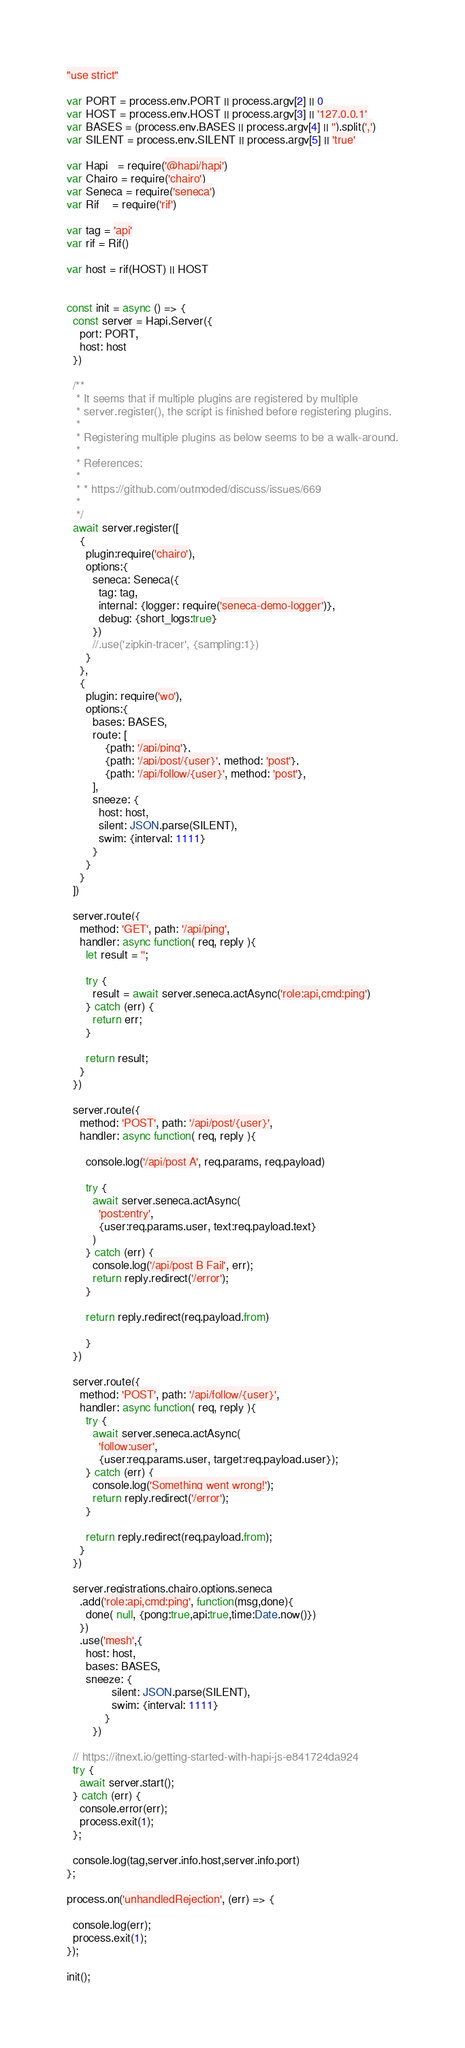<code> <loc_0><loc_0><loc_500><loc_500><_JavaScript_>"use strict"

var PORT = process.env.PORT || process.argv[2] || 0
var HOST = process.env.HOST || process.argv[3] || '127.0.0.1'
var BASES = (process.env.BASES || process.argv[4] || '').split(',')
var SILENT = process.env.SILENT || process.argv[5] || 'true'

var Hapi   = require('@hapi/hapi')
var Chairo = require('chairo')
var Seneca = require('seneca')
var Rif    = require('rif')

var tag = 'api'
var rif = Rif()

var host = rif(HOST) || HOST


const init = async () => {
  const server = Hapi.Server({
    port: PORT,
    host: host
  })
  
  /**
   * It seems that if multiple plugins are registered by multiple
   * server.register(), the script is finished before registering plugins.
   * 
   * Registering multiple plugins as below seems to be a walk-around.
   * 
   * References:
   * 
   * * https://github.com/outmoded/discuss/issues/669
   * 
   */
  await server.register([
    {
      plugin:require('chairo'),
      options:{
        seneca: Seneca({
          tag: tag,
          internal: {logger: require('seneca-demo-logger')},
          debug: {short_logs:true}
        })
        //.use('zipkin-tracer', {sampling:1})
      }
    },
    {
      plugin: require('wo'),
      options:{
        bases: BASES,
        route: [
            {path: '/api/ping'},
            {path: '/api/post/{user}', method: 'post'},
            {path: '/api/follow/{user}', method: 'post'},
        ],
        sneeze: {
          host: host,
          silent: JSON.parse(SILENT),
          swim: {interval: 1111}
        }
      }
    }
  ])

  server.route({
    method: 'GET', path: '/api/ping',
    handler: async function( req, reply ){
      let result = '';

      try {
        result = await server.seneca.actAsync('role:api,cmd:ping')
      } catch (err) {
        return err;
      }

      return result;
    }
  })
  
  server.route({
    method: 'POST', path: '/api/post/{user}',
    handler: async function( req, reply ){
  
      console.log('/api/post A', req.params, req.payload)
      
      try {
        await server.seneca.actAsync(
          'post:entry',
          {user:req.params.user, text:req.payload.text}
        )
      } catch (err) {
        console.log('/api/post B Fail', err);
        return reply.redirect('/error');
      }

      return reply.redirect(req.payload.from)

      }
  })
  
  server.route({
    method: 'POST', path: '/api/follow/{user}',
    handler: async function( req, reply ){
      try {
        await server.seneca.actAsync(
          'follow:user',
          {user:req.params.user, target:req.payload.user});
      } catch (err) {
        console.log('Something went wrong!');
        return reply.redirect('/error');
      }

      return reply.redirect(req.payload.from);
    }
  })

  server.registrations.chairo.options.seneca
    .add('role:api,cmd:ping', function(msg,done){
      done( null, {pong:true,api:true,time:Date.now()})
    })
    .use('mesh',{
      host: host,
      bases: BASES,
      sneeze: {
              silent: JSON.parse(SILENT),
              swim: {interval: 1111}
            }
        })
        
  // https://itnext.io/getting-started-with-hapi-js-e841724da924
  try {
    await server.start();
  } catch (err) {
    console.error(err);
    process.exit(1);
  };

  console.log(tag,server.info.host,server.info.port)
};

process.on('unhandledRejection', (err) => {

  console.log(err);
  process.exit(1);
});

init();</code> 